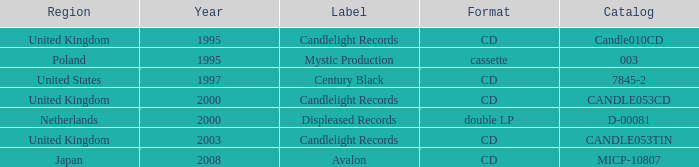Give me the full table as a dictionary. {'header': ['Region', 'Year', 'Label', 'Format', 'Catalog'], 'rows': [['United Kingdom', '1995', 'Candlelight Records', 'CD', 'Candle010CD'], ['Poland', '1995', 'Mystic Production', 'cassette', '003'], ['United States', '1997', 'Century Black', 'CD', '7845-2'], ['United Kingdom', '2000', 'Candlelight Records', 'CD', 'CANDLE053CD'], ['Netherlands', '2000', 'Displeased Records', 'double LP', 'D-00081'], ['United Kingdom', '2003', 'Candlelight Records', 'CD', 'CANDLE053TIN'], ['Japan', '2008', 'Avalon', 'CD', 'MICP-10807']]} What year did Japan form a label? 2008.0. 